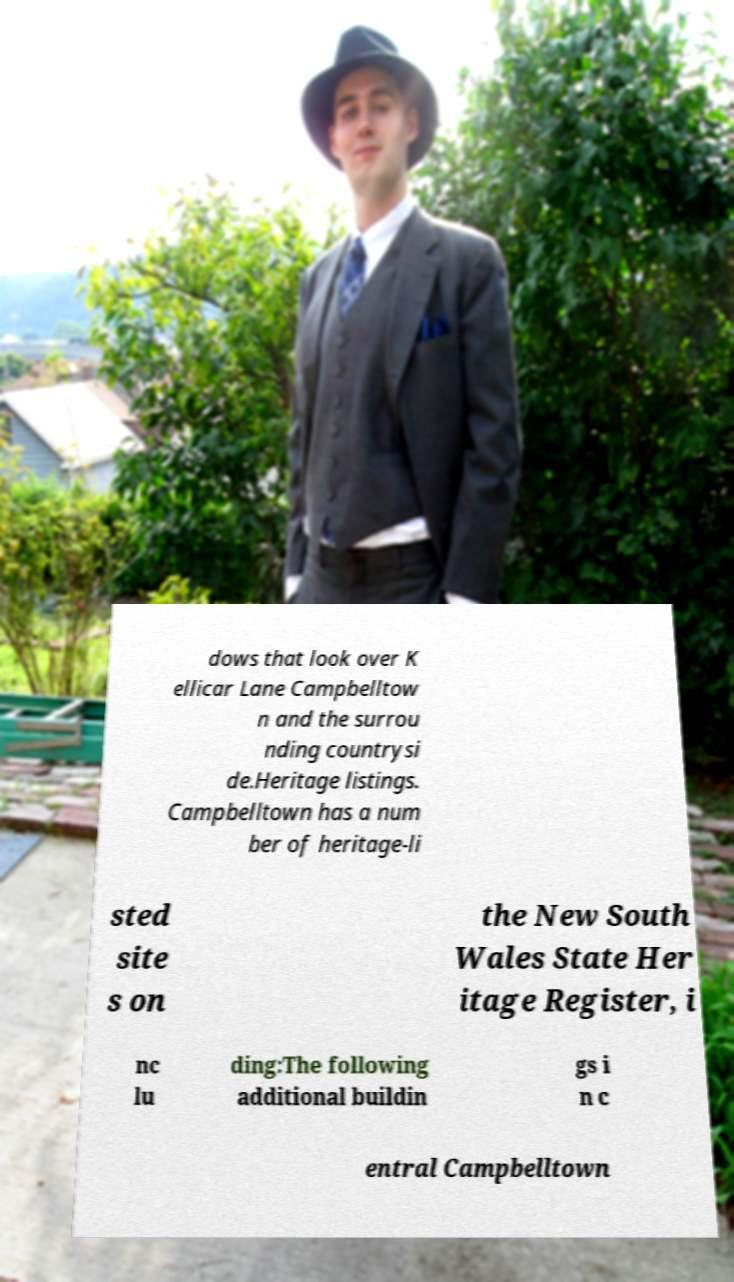Can you read and provide the text displayed in the image?This photo seems to have some interesting text. Can you extract and type it out for me? dows that look over K ellicar Lane Campbelltow n and the surrou nding countrysi de.Heritage listings. Campbelltown has a num ber of heritage-li sted site s on the New South Wales State Her itage Register, i nc lu ding:The following additional buildin gs i n c entral Campbelltown 